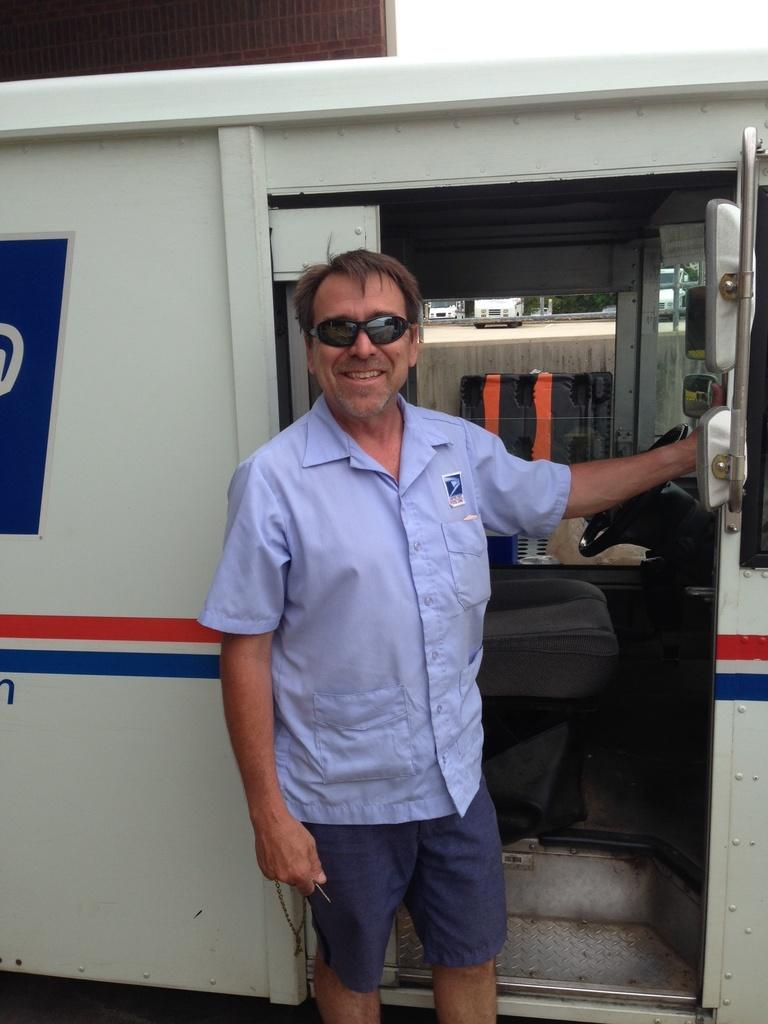What is the person in the image doing? The person is holding a door of a vehicle. What is the person wearing in the image? The person is wearing a blue color shirt. What is the person's facial expression in the image? The person is smiling. What can be seen in the background of the image? There are vehicles and other objects in the background of the image. What type of vest is the person wearing in the image? There is no vest visible in the image; the person is wearing a blue color shirt. Who is the owner of the vehicle in the image? The image does not provide information about the ownership of the vehicle. 